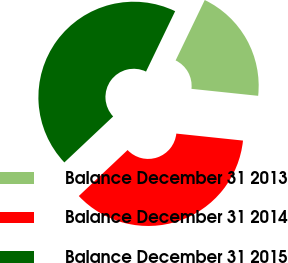Convert chart to OTSL. <chart><loc_0><loc_0><loc_500><loc_500><pie_chart><fcel>Balance December 31 2013<fcel>Balance December 31 2014<fcel>Balance December 31 2015<nl><fcel>19.51%<fcel>36.31%<fcel>44.18%<nl></chart> 